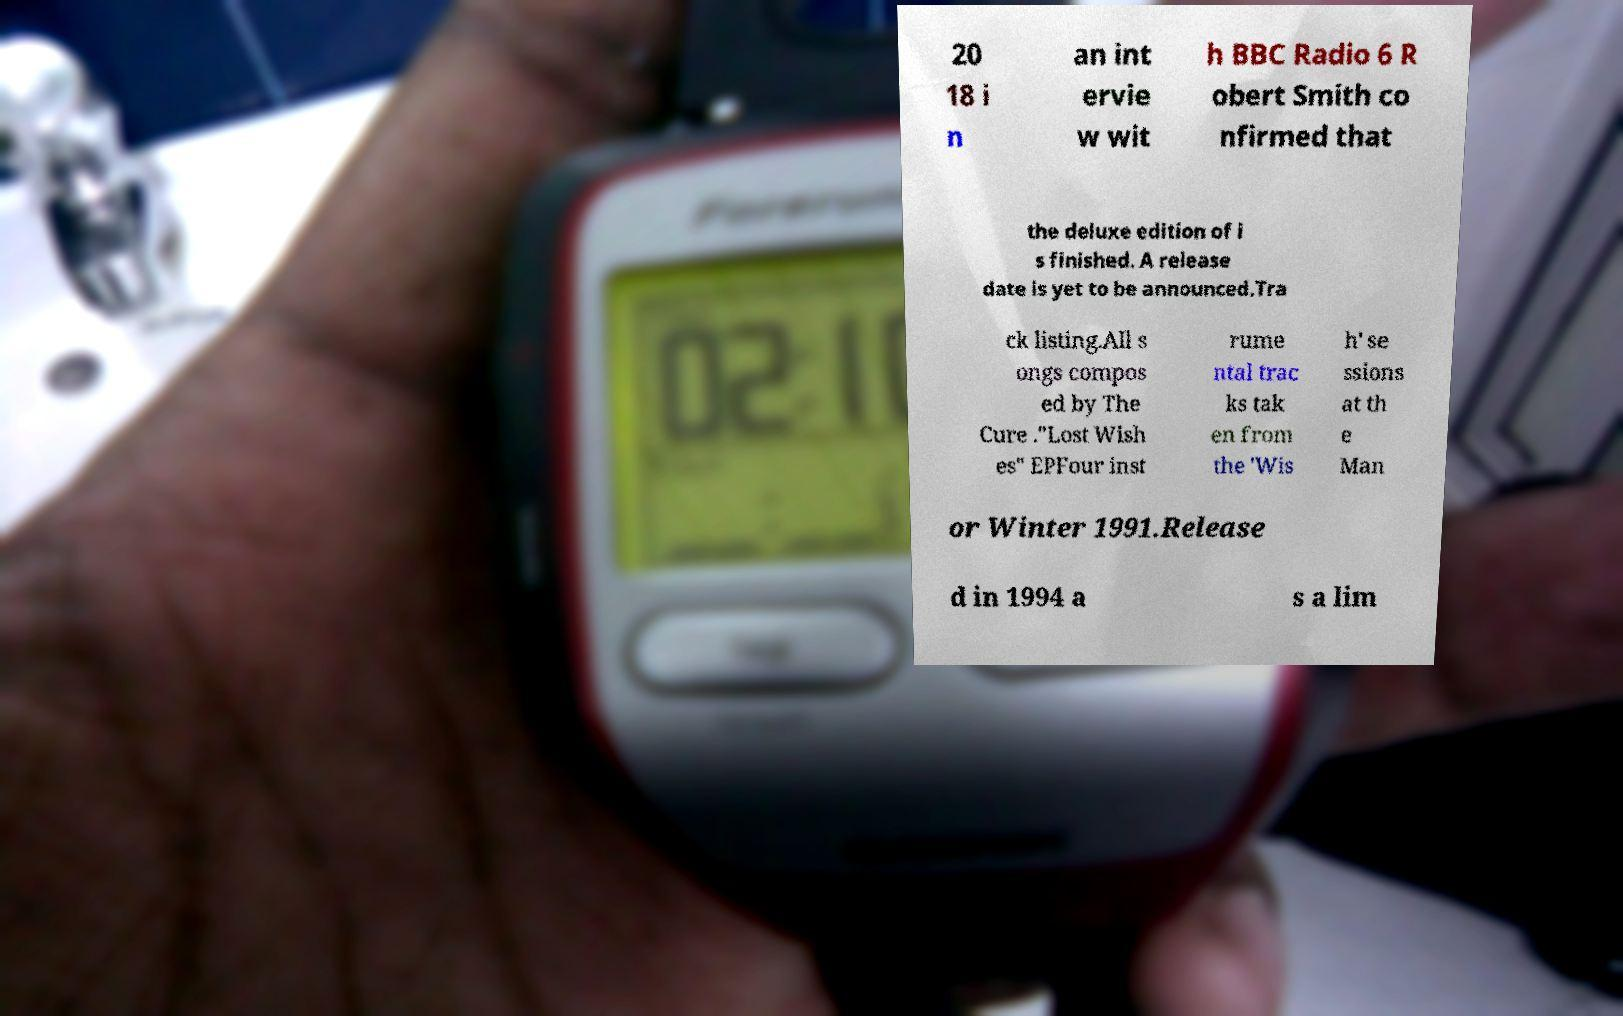Can you read and provide the text displayed in the image?This photo seems to have some interesting text. Can you extract and type it out for me? 20 18 i n an int ervie w wit h BBC Radio 6 R obert Smith co nfirmed that the deluxe edition of i s finished. A release date is yet to be announced.Tra ck listing.All s ongs compos ed by The Cure ."Lost Wish es" EPFour inst rume ntal trac ks tak en from the 'Wis h' se ssions at th e Man or Winter 1991.Release d in 1994 a s a lim 